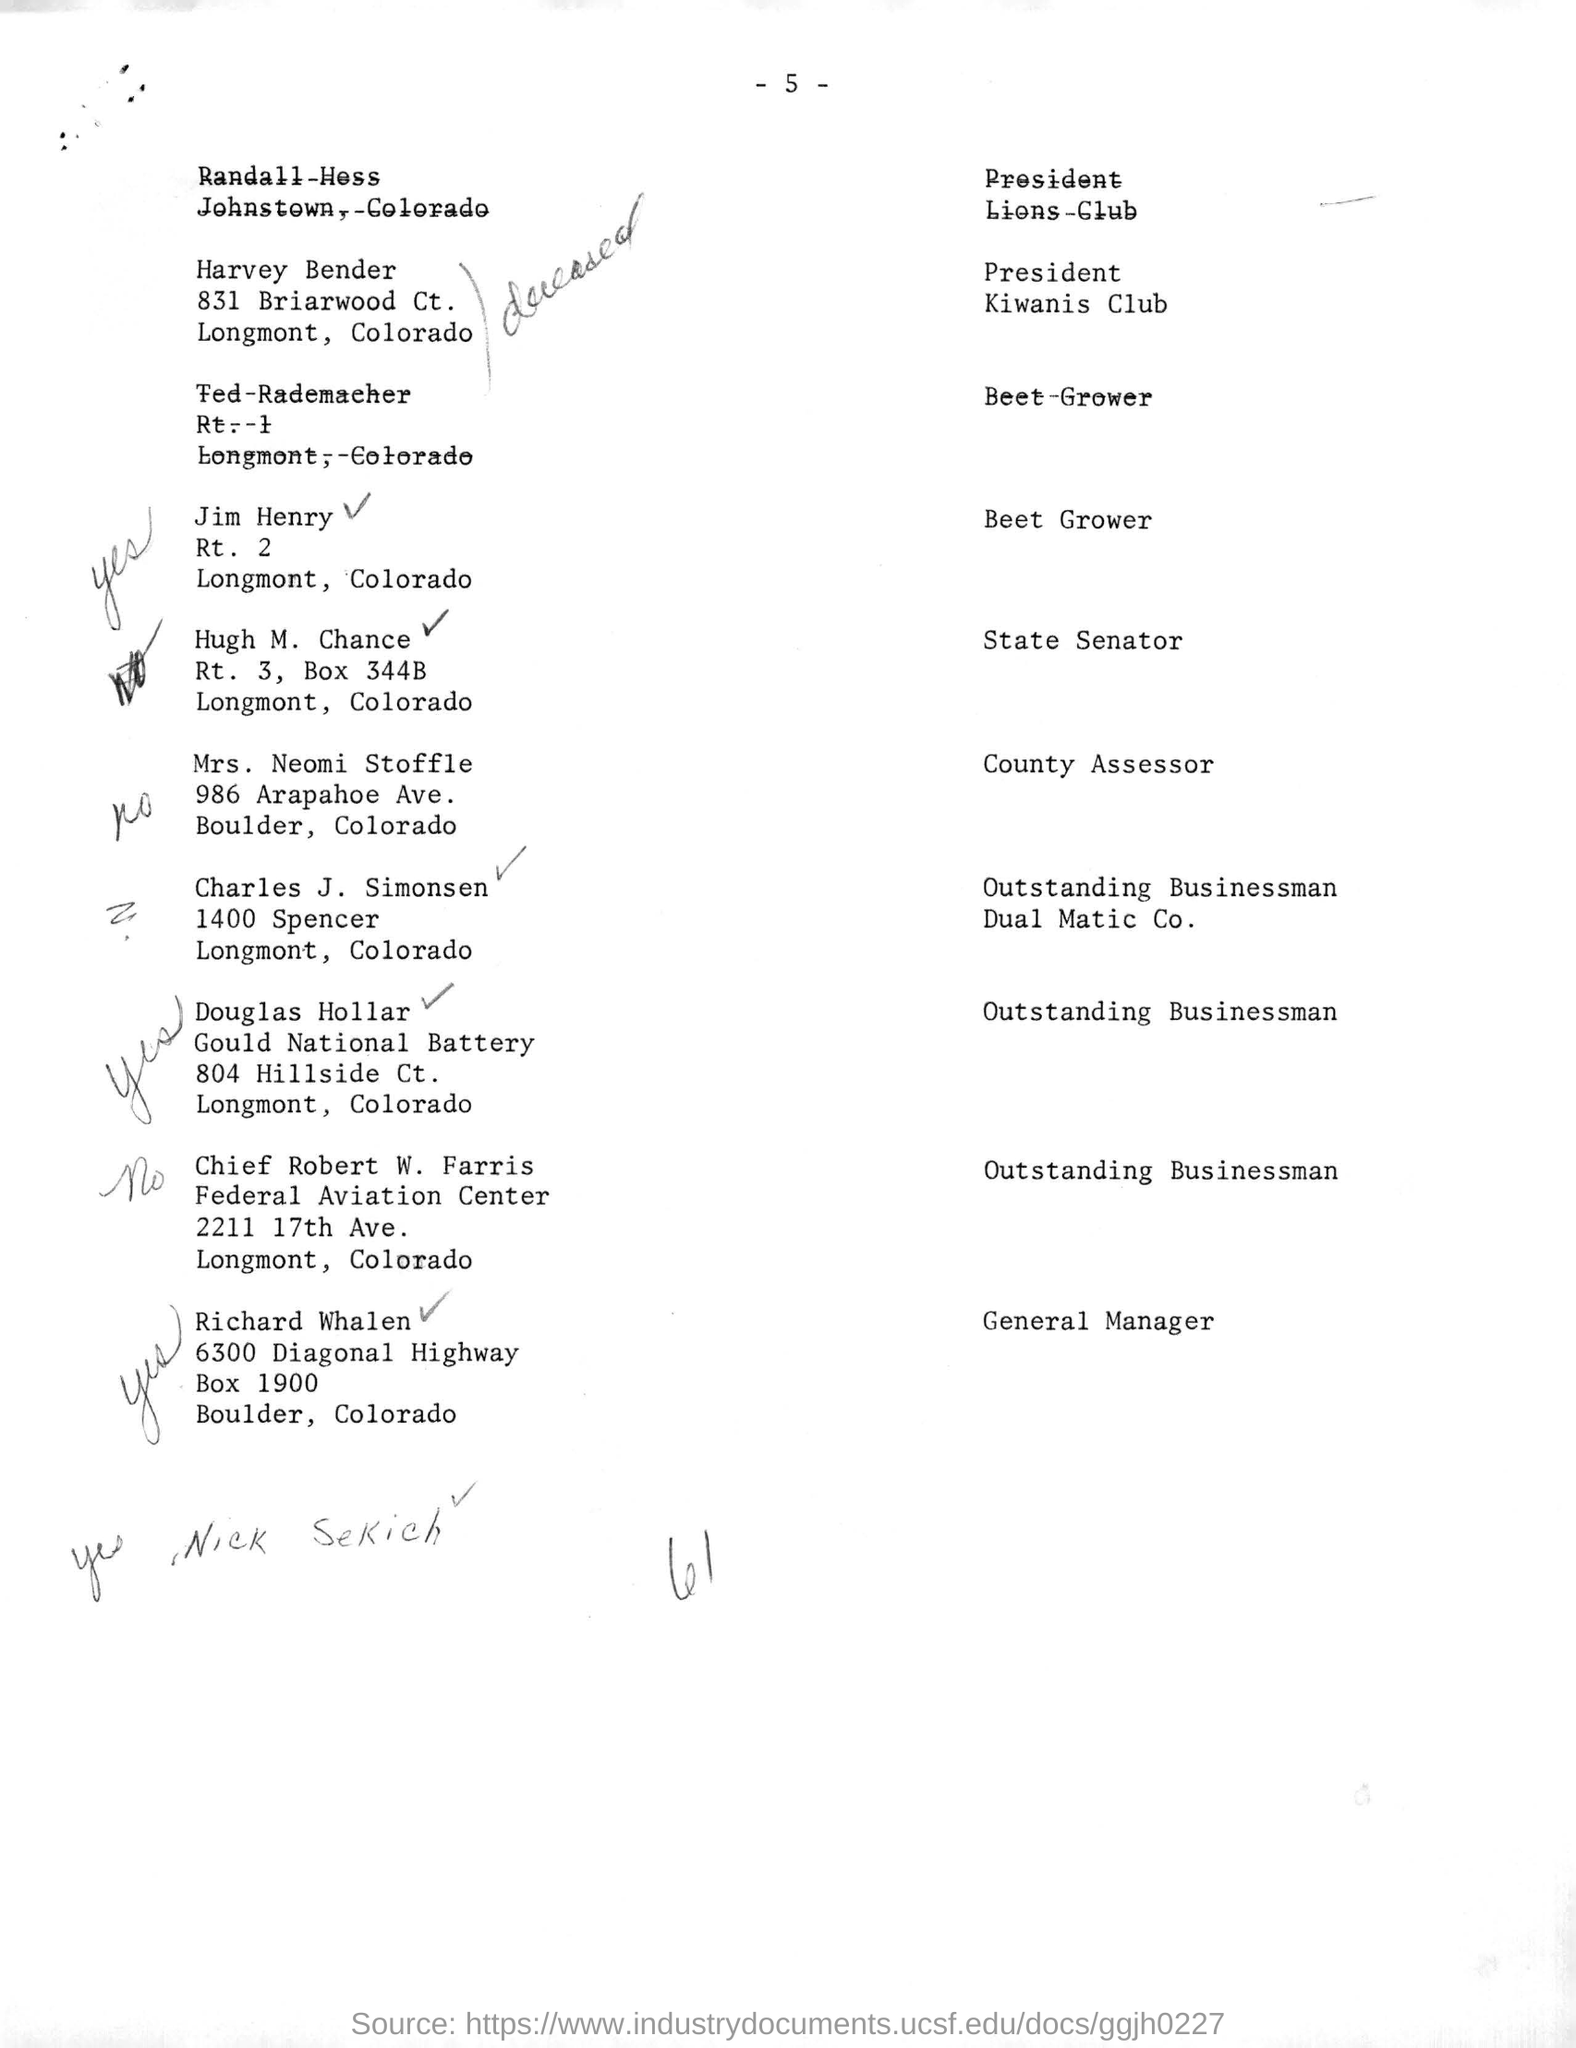Highlight a few significant elements in this photo. Mrs. Neomi Stoffle is the county assessor. The post box number for 6300 Diagonal Highway in Boulder, Colorado is 1900. Harvey Bender, a member of the Kiwanis club, holds the designation of PRESIDENT. It has been officially designated that Richard Whalen is the general manager. Charles J. Simonsen is known as an outstanding businessman for Dual Matic Co. 